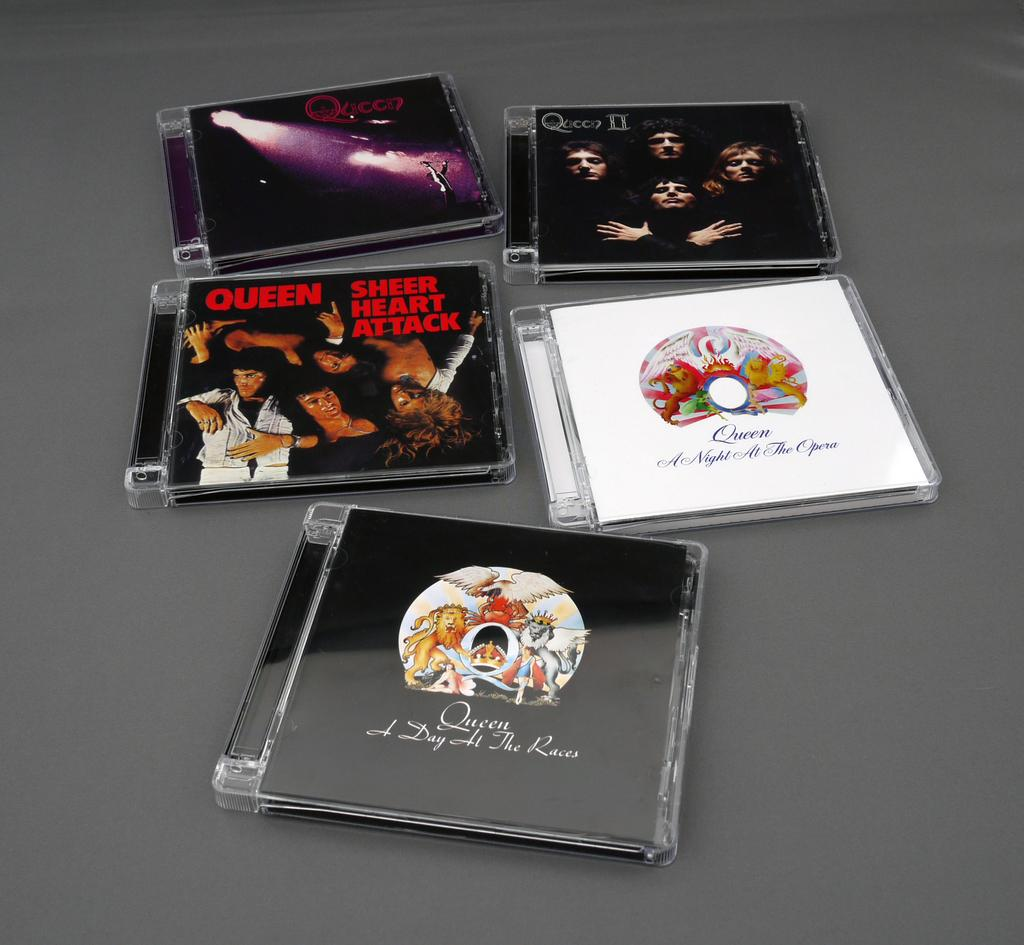How many CD cases are visible in the image? There are five CD cases in the image. What is depicted on the CD cases? The CD cases have movie posters on them. What colors are the CD cases? Four of the CD cases are black, and one is white. What level of wilderness can be seen in the image? There is no wilderness present in the image; it features CD cases with movie posters. 